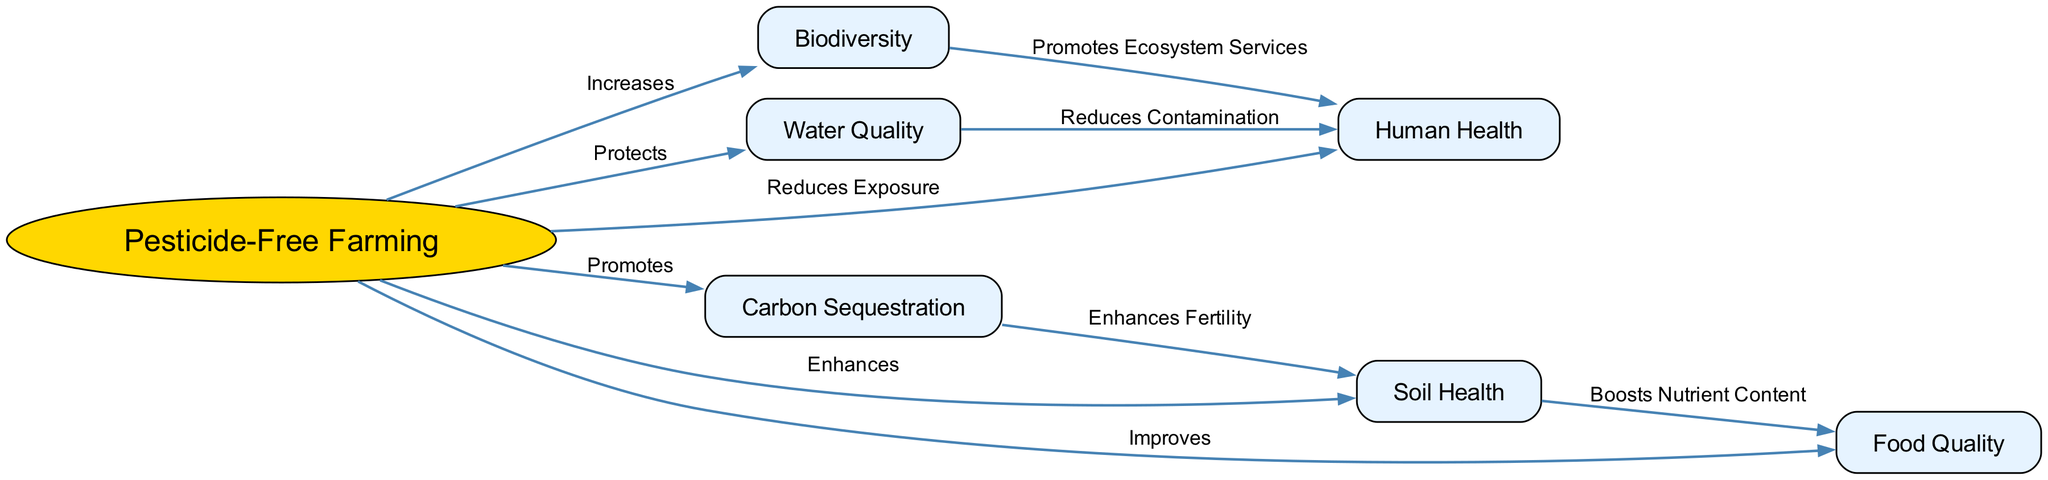What is the central concept of the diagram? The diagram centers on "Pesticide-Free Farming," depicted as the main node from which various ecological impacts stem. It is the only node represented as an ellipse, emphasizing its significance in the diagram.
Answer: Pesticide-Free Farming How many total nodes are shown in the diagram? By counting each unique node, we find there are seven nodes: "Pesticide-Free Farming," "Soil Health," "Biodiversity," "Water Quality," "Human Health," "Food Quality," and "Carbon Sequestration."
Answer: Seven What relationship does "Pesticide-Free Farming" have with "Water Quality"? The diagram shows that "Pesticide-Free Farming" "Protects" "Water Quality," indicating a direct positive effect. This is one of the relationships clearly illustrated in the diagram.
Answer: Protects What impact does "Biodiversity" have on "Human Health"? "Biodiversity" "Promotes Ecosystem Services," which indirectly benefits "Human Health." By examining the connections, we can see that increased biodiversity leads to more services that humans rely on, promoting overall health.
Answer: Promotes Ecosystem Services Which node is affected by "Carbon Sequestration"? "Carbon Sequestration" directly "Enhances Fertility" of "Soil Health," illustrating a beneficial impact that helps improve soil quality which is crucial for farming practices.
Answer: Enhances Fertility What is the effect of "Pesticide-Free Farming" on "Food Quality"? The diagram shows that "Pesticide-Free Farming" "Improves" "Food Quality," indicating that farming without pesticides results in better quality food products. This is a direct positive relationship evidenced in the diagram.
Answer: Improves How does "Soil Health" influence "Food Quality"? The link states that "Soil Health" "Boosts Nutrient Content," which leads to improved "Food Quality." This implies a chain effect where healthy soil translates to better nutrients available in the crops.
Answer: Boosts Nutrient Content 